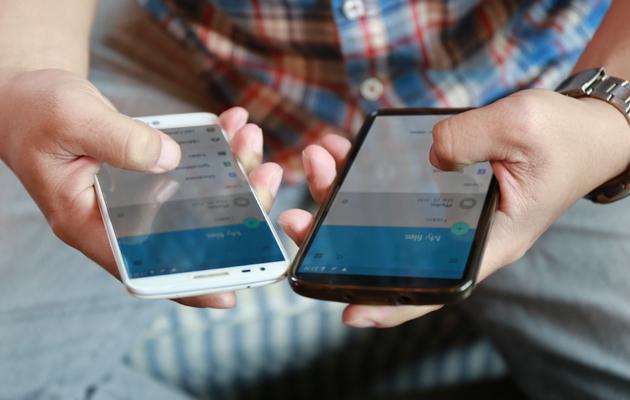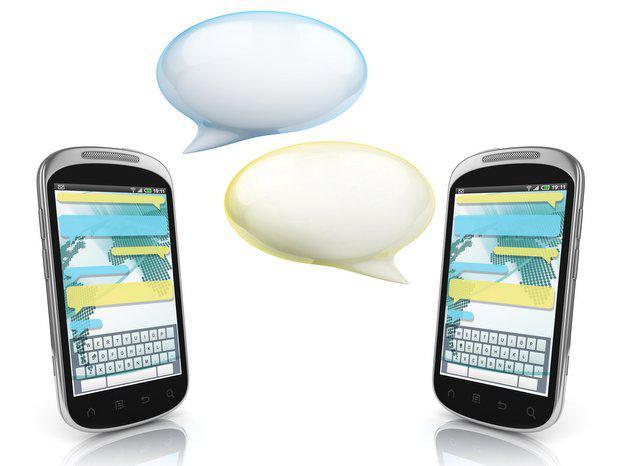The first image is the image on the left, the second image is the image on the right. Evaluate the accuracy of this statement regarding the images: "The left image features two palms-up hands, each holding a screen-side up phone next to the other phone.". Is it true? Answer yes or no. Yes. The first image is the image on the left, the second image is the image on the right. Assess this claim about the two images: "The left and right image contains a total of four phones.". Correct or not? Answer yes or no. Yes. 